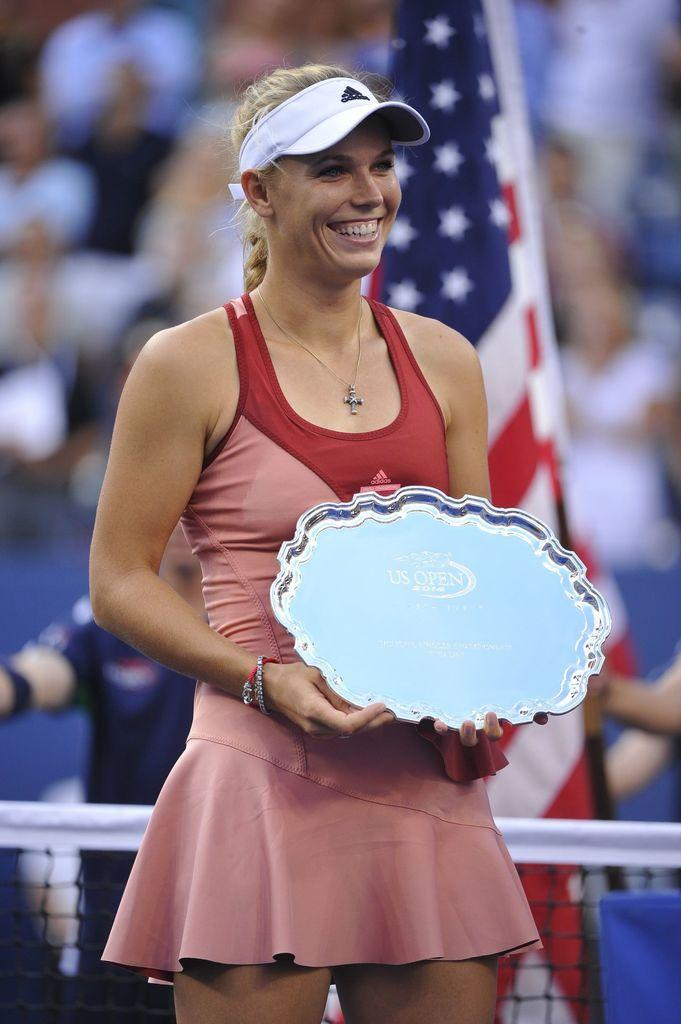Who is the main subject in the image? There is a lady in the image. What is the lady wearing on her head? The lady is wearing a cap. What is the lady holding in her hand? The lady is holding something in her hand. What can be seen in the background of the image? There is a flag and people in the background of the image. What object is present in the image that resembles a net? There is a net in the image. What type of wren can be seen flying in the image? There is no wren present in the image; it features a lady wearing a cap, holding something, and standing in front of a flag and people. How does the lady get into trouble in the image? There is no indication of trouble or any negative situation involving the lady in the image. 